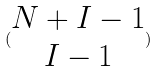Convert formula to latex. <formula><loc_0><loc_0><loc_500><loc_500>( \begin{matrix} N + I - 1 \\ I - 1 \end{matrix} )</formula> 